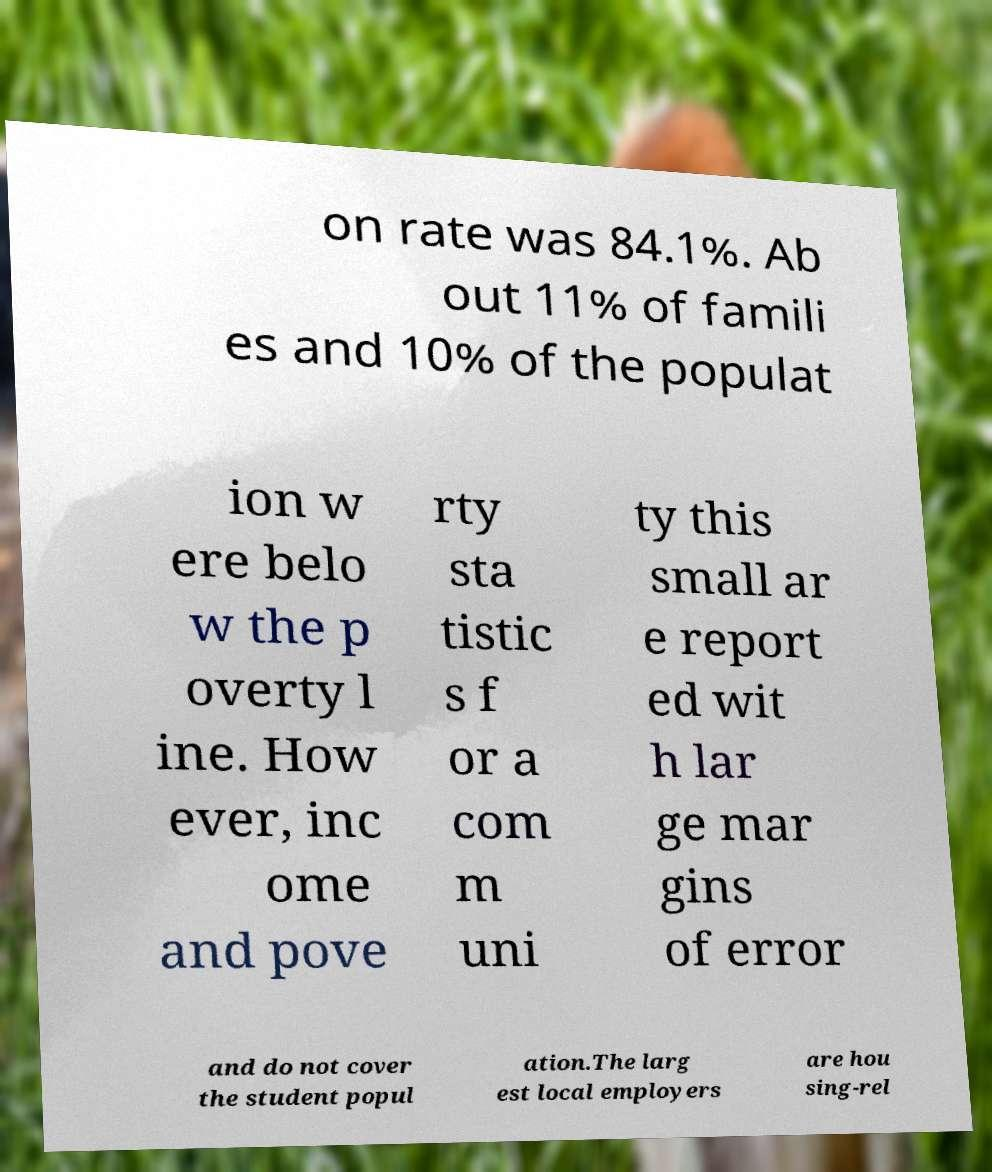I need the written content from this picture converted into text. Can you do that? on rate was 84.1%. Ab out 11% of famili es and 10% of the populat ion w ere belo w the p overty l ine. How ever, inc ome and pove rty sta tistic s f or a com m uni ty this small ar e report ed wit h lar ge mar gins of error and do not cover the student popul ation.The larg est local employers are hou sing-rel 